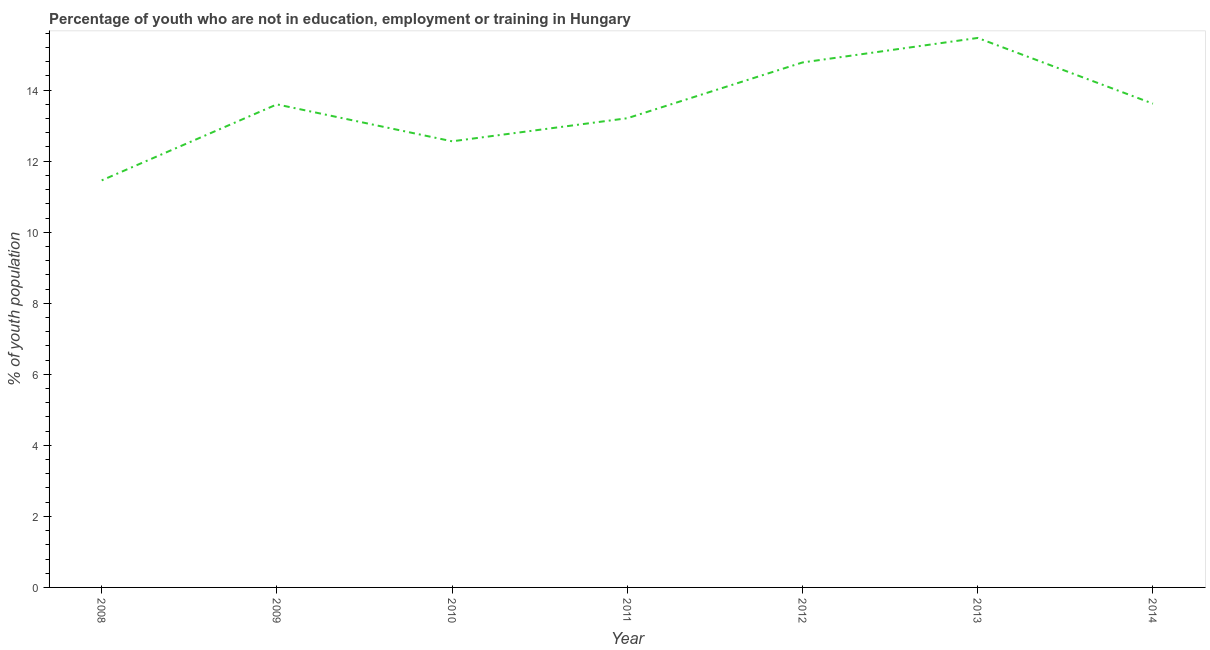What is the unemployed youth population in 2008?
Provide a short and direct response. 11.46. Across all years, what is the maximum unemployed youth population?
Offer a very short reply. 15.47. Across all years, what is the minimum unemployed youth population?
Provide a short and direct response. 11.46. In which year was the unemployed youth population maximum?
Give a very brief answer. 2013. What is the sum of the unemployed youth population?
Your answer should be compact. 94.7. What is the difference between the unemployed youth population in 2012 and 2014?
Your response must be concise. 1.16. What is the average unemployed youth population per year?
Offer a very short reply. 13.53. What is the median unemployed youth population?
Offer a terse response. 13.6. In how many years, is the unemployed youth population greater than 10.8 %?
Your response must be concise. 7. What is the ratio of the unemployed youth population in 2008 to that in 2012?
Make the answer very short. 0.78. What is the difference between the highest and the second highest unemployed youth population?
Offer a terse response. 0.69. What is the difference between the highest and the lowest unemployed youth population?
Provide a succinct answer. 4.01. In how many years, is the unemployed youth population greater than the average unemployed youth population taken over all years?
Ensure brevity in your answer.  4. Are the values on the major ticks of Y-axis written in scientific E-notation?
Provide a succinct answer. No. Does the graph contain any zero values?
Your response must be concise. No. What is the title of the graph?
Make the answer very short. Percentage of youth who are not in education, employment or training in Hungary. What is the label or title of the Y-axis?
Your answer should be very brief. % of youth population. What is the % of youth population of 2008?
Your answer should be very brief. 11.46. What is the % of youth population of 2009?
Offer a terse response. 13.6. What is the % of youth population in 2010?
Provide a succinct answer. 12.56. What is the % of youth population in 2011?
Provide a short and direct response. 13.21. What is the % of youth population in 2012?
Your response must be concise. 14.78. What is the % of youth population in 2013?
Your answer should be very brief. 15.47. What is the % of youth population in 2014?
Your response must be concise. 13.62. What is the difference between the % of youth population in 2008 and 2009?
Provide a succinct answer. -2.14. What is the difference between the % of youth population in 2008 and 2010?
Make the answer very short. -1.1. What is the difference between the % of youth population in 2008 and 2011?
Your answer should be very brief. -1.75. What is the difference between the % of youth population in 2008 and 2012?
Ensure brevity in your answer.  -3.32. What is the difference between the % of youth population in 2008 and 2013?
Make the answer very short. -4.01. What is the difference between the % of youth population in 2008 and 2014?
Ensure brevity in your answer.  -2.16. What is the difference between the % of youth population in 2009 and 2011?
Ensure brevity in your answer.  0.39. What is the difference between the % of youth population in 2009 and 2012?
Provide a short and direct response. -1.18. What is the difference between the % of youth population in 2009 and 2013?
Offer a terse response. -1.87. What is the difference between the % of youth population in 2009 and 2014?
Your answer should be compact. -0.02. What is the difference between the % of youth population in 2010 and 2011?
Provide a short and direct response. -0.65. What is the difference between the % of youth population in 2010 and 2012?
Your response must be concise. -2.22. What is the difference between the % of youth population in 2010 and 2013?
Provide a short and direct response. -2.91. What is the difference between the % of youth population in 2010 and 2014?
Keep it short and to the point. -1.06. What is the difference between the % of youth population in 2011 and 2012?
Keep it short and to the point. -1.57. What is the difference between the % of youth population in 2011 and 2013?
Your response must be concise. -2.26. What is the difference between the % of youth population in 2011 and 2014?
Ensure brevity in your answer.  -0.41. What is the difference between the % of youth population in 2012 and 2013?
Give a very brief answer. -0.69. What is the difference between the % of youth population in 2012 and 2014?
Your answer should be very brief. 1.16. What is the difference between the % of youth population in 2013 and 2014?
Provide a short and direct response. 1.85. What is the ratio of the % of youth population in 2008 to that in 2009?
Keep it short and to the point. 0.84. What is the ratio of the % of youth population in 2008 to that in 2010?
Provide a succinct answer. 0.91. What is the ratio of the % of youth population in 2008 to that in 2011?
Ensure brevity in your answer.  0.87. What is the ratio of the % of youth population in 2008 to that in 2012?
Provide a short and direct response. 0.78. What is the ratio of the % of youth population in 2008 to that in 2013?
Give a very brief answer. 0.74. What is the ratio of the % of youth population in 2008 to that in 2014?
Ensure brevity in your answer.  0.84. What is the ratio of the % of youth population in 2009 to that in 2010?
Offer a very short reply. 1.08. What is the ratio of the % of youth population in 2009 to that in 2011?
Ensure brevity in your answer.  1.03. What is the ratio of the % of youth population in 2009 to that in 2013?
Your response must be concise. 0.88. What is the ratio of the % of youth population in 2010 to that in 2011?
Make the answer very short. 0.95. What is the ratio of the % of youth population in 2010 to that in 2012?
Ensure brevity in your answer.  0.85. What is the ratio of the % of youth population in 2010 to that in 2013?
Keep it short and to the point. 0.81. What is the ratio of the % of youth population in 2010 to that in 2014?
Your answer should be very brief. 0.92. What is the ratio of the % of youth population in 2011 to that in 2012?
Your response must be concise. 0.89. What is the ratio of the % of youth population in 2011 to that in 2013?
Offer a very short reply. 0.85. What is the ratio of the % of youth population in 2011 to that in 2014?
Provide a succinct answer. 0.97. What is the ratio of the % of youth population in 2012 to that in 2013?
Ensure brevity in your answer.  0.95. What is the ratio of the % of youth population in 2012 to that in 2014?
Keep it short and to the point. 1.08. What is the ratio of the % of youth population in 2013 to that in 2014?
Provide a short and direct response. 1.14. 